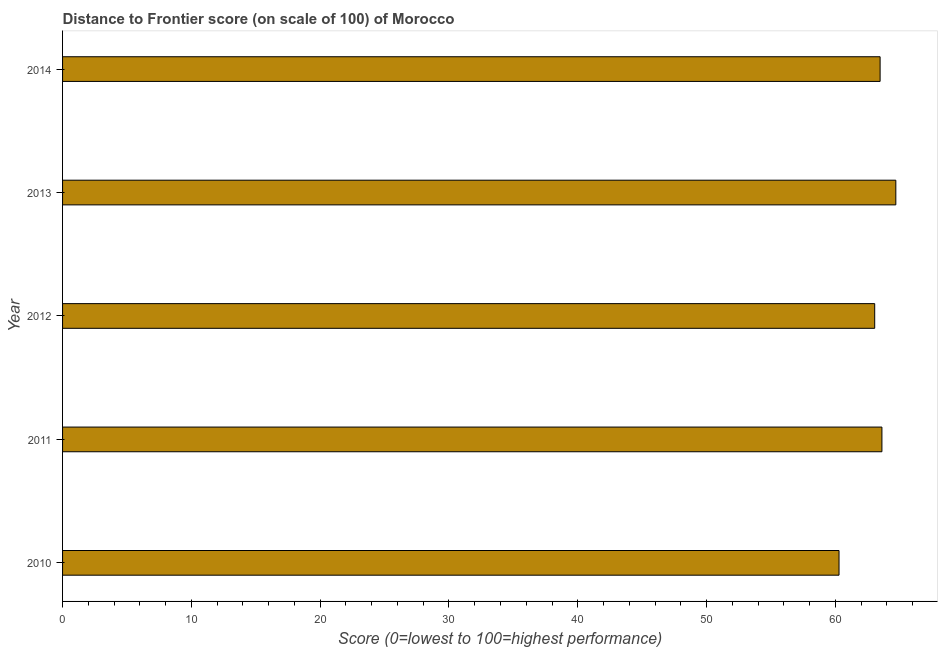Does the graph contain grids?
Your answer should be very brief. No. What is the title of the graph?
Ensure brevity in your answer.  Distance to Frontier score (on scale of 100) of Morocco. What is the label or title of the X-axis?
Ensure brevity in your answer.  Score (0=lowest to 100=highest performance). What is the distance to frontier score in 2014?
Your response must be concise. 63.47. Across all years, what is the maximum distance to frontier score?
Your response must be concise. 64.69. Across all years, what is the minimum distance to frontier score?
Offer a very short reply. 60.28. In which year was the distance to frontier score maximum?
Your answer should be compact. 2013. In which year was the distance to frontier score minimum?
Your answer should be very brief. 2010. What is the sum of the distance to frontier score?
Offer a terse response. 315.1. What is the difference between the distance to frontier score in 2011 and 2013?
Make the answer very short. -1.08. What is the average distance to frontier score per year?
Your answer should be very brief. 63.02. What is the median distance to frontier score?
Make the answer very short. 63.47. In how many years, is the distance to frontier score greater than 28 ?
Give a very brief answer. 5. Do a majority of the years between 2014 and 2012 (inclusive) have distance to frontier score greater than 62 ?
Your response must be concise. Yes. What is the ratio of the distance to frontier score in 2010 to that in 2011?
Your answer should be compact. 0.95. Is the distance to frontier score in 2010 less than that in 2011?
Your answer should be compact. Yes. What is the difference between the highest and the lowest distance to frontier score?
Give a very brief answer. 4.41. In how many years, is the distance to frontier score greater than the average distance to frontier score taken over all years?
Your answer should be compact. 4. Are all the bars in the graph horizontal?
Your answer should be very brief. Yes. What is the Score (0=lowest to 100=highest performance) in 2010?
Make the answer very short. 60.28. What is the Score (0=lowest to 100=highest performance) of 2011?
Your response must be concise. 63.61. What is the Score (0=lowest to 100=highest performance) in 2012?
Give a very brief answer. 63.05. What is the Score (0=lowest to 100=highest performance) of 2013?
Give a very brief answer. 64.69. What is the Score (0=lowest to 100=highest performance) in 2014?
Give a very brief answer. 63.47. What is the difference between the Score (0=lowest to 100=highest performance) in 2010 and 2011?
Offer a terse response. -3.33. What is the difference between the Score (0=lowest to 100=highest performance) in 2010 and 2012?
Provide a short and direct response. -2.77. What is the difference between the Score (0=lowest to 100=highest performance) in 2010 and 2013?
Your answer should be compact. -4.41. What is the difference between the Score (0=lowest to 100=highest performance) in 2010 and 2014?
Provide a short and direct response. -3.19. What is the difference between the Score (0=lowest to 100=highest performance) in 2011 and 2012?
Provide a short and direct response. 0.56. What is the difference between the Score (0=lowest to 100=highest performance) in 2011 and 2013?
Provide a short and direct response. -1.08. What is the difference between the Score (0=lowest to 100=highest performance) in 2011 and 2014?
Give a very brief answer. 0.14. What is the difference between the Score (0=lowest to 100=highest performance) in 2012 and 2013?
Provide a short and direct response. -1.64. What is the difference between the Score (0=lowest to 100=highest performance) in 2012 and 2014?
Provide a short and direct response. -0.42. What is the difference between the Score (0=lowest to 100=highest performance) in 2013 and 2014?
Provide a succinct answer. 1.22. What is the ratio of the Score (0=lowest to 100=highest performance) in 2010 to that in 2011?
Your answer should be compact. 0.95. What is the ratio of the Score (0=lowest to 100=highest performance) in 2010 to that in 2012?
Make the answer very short. 0.96. What is the ratio of the Score (0=lowest to 100=highest performance) in 2010 to that in 2013?
Ensure brevity in your answer.  0.93. What is the ratio of the Score (0=lowest to 100=highest performance) in 2011 to that in 2014?
Give a very brief answer. 1. What is the ratio of the Score (0=lowest to 100=highest performance) in 2012 to that in 2013?
Provide a short and direct response. 0.97. What is the ratio of the Score (0=lowest to 100=highest performance) in 2012 to that in 2014?
Your answer should be compact. 0.99. What is the ratio of the Score (0=lowest to 100=highest performance) in 2013 to that in 2014?
Give a very brief answer. 1.02. 